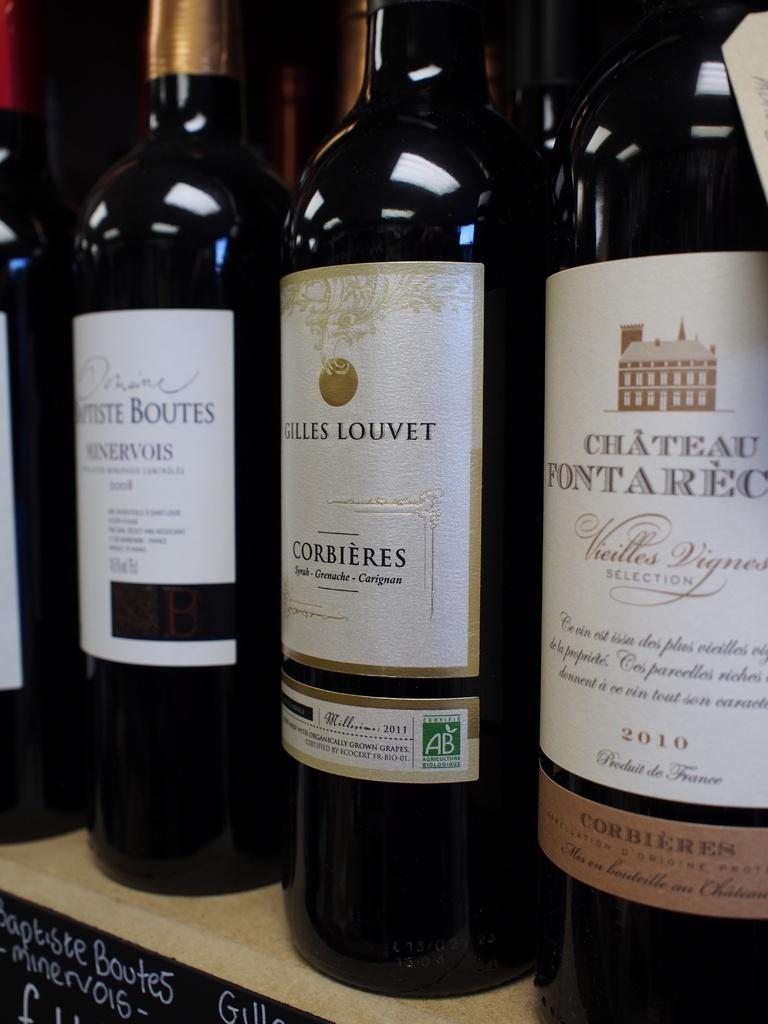<image>
Create a compact narrative representing the image presented. the word chateau that is on one of the bottles 